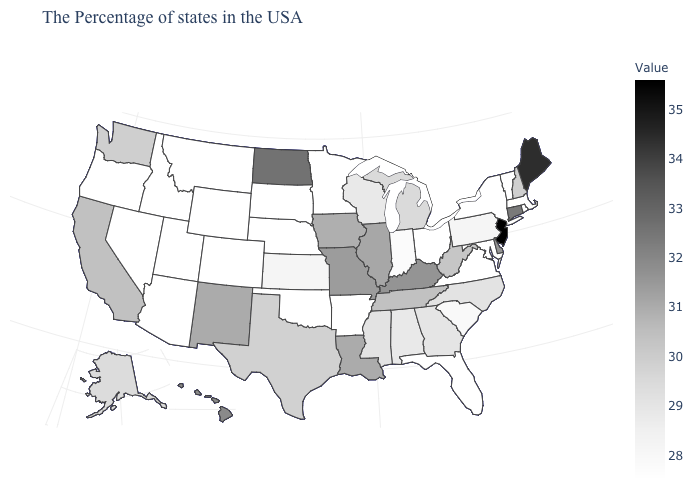Which states hav the highest value in the South?
Give a very brief answer. Delaware, Kentucky. Among the states that border Wisconsin , which have the highest value?
Answer briefly. Illinois. Does New Jersey have the highest value in the Northeast?
Give a very brief answer. Yes. Does Delaware have a higher value than Nebraska?
Be succinct. Yes. 